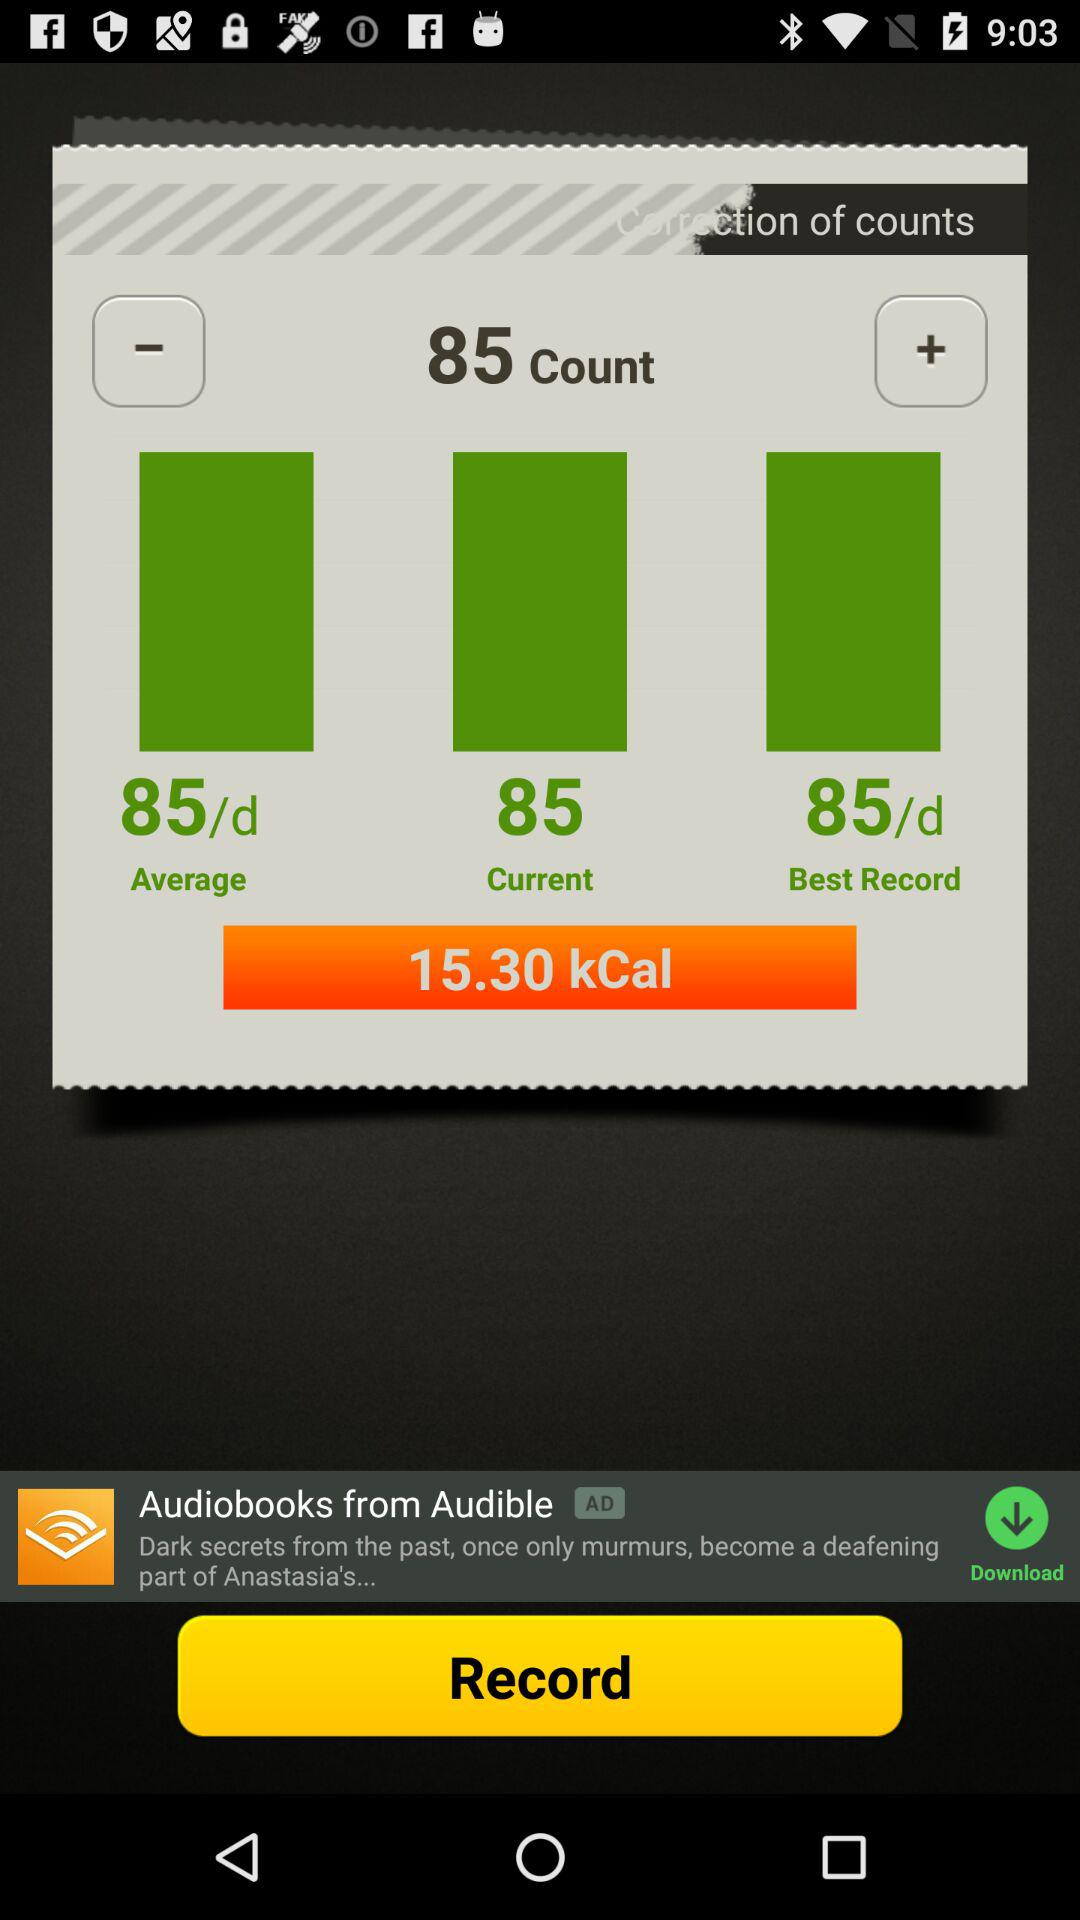What is the best record? The best record is 85 per day. 